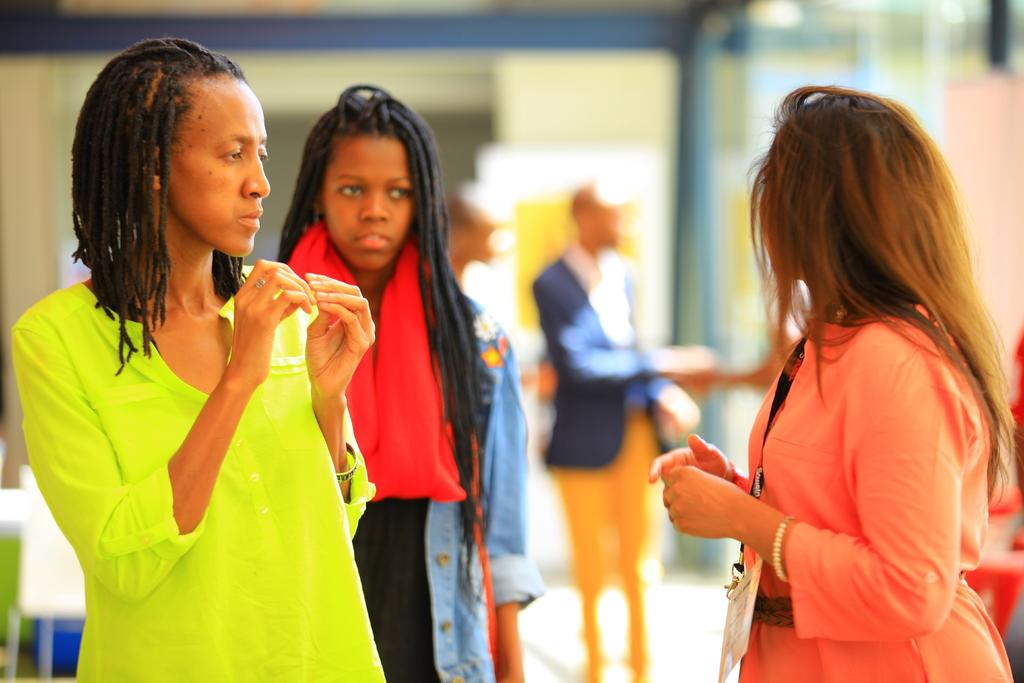Who or what can be seen in the image? There are people in the image. What are the people doing in the image? The people are standing on the floor. What is the price of the squirrel in the image? There is no squirrel present in the image, so there is no price to determine. 